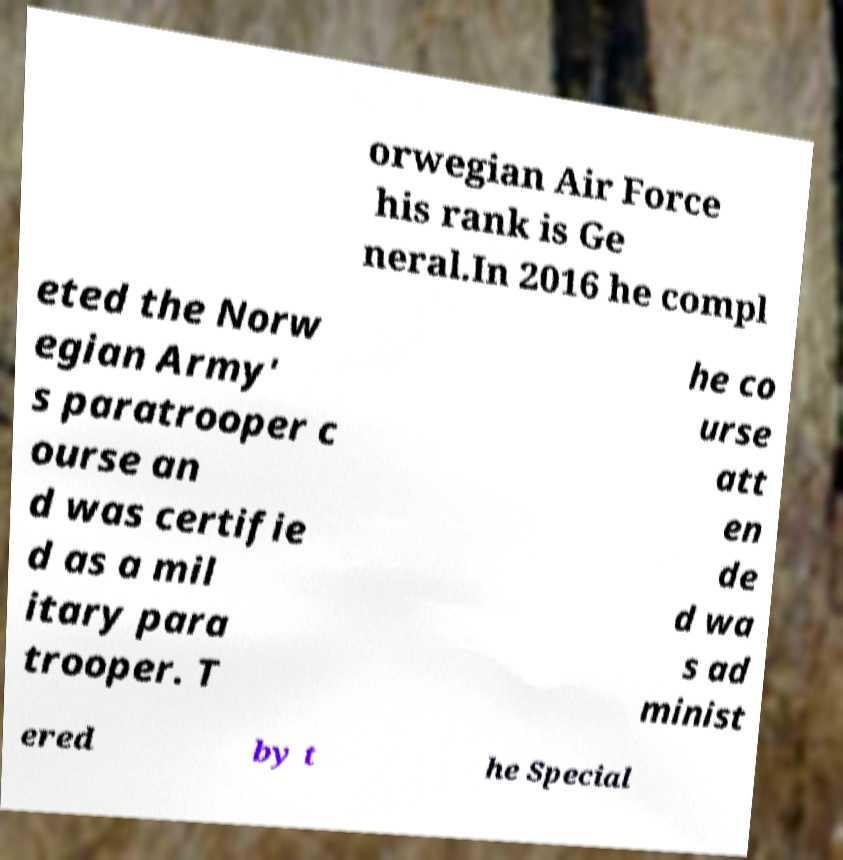For documentation purposes, I need the text within this image transcribed. Could you provide that? orwegian Air Force his rank is Ge neral.In 2016 he compl eted the Norw egian Army' s paratrooper c ourse an d was certifie d as a mil itary para trooper. T he co urse att en de d wa s ad minist ered by t he Special 